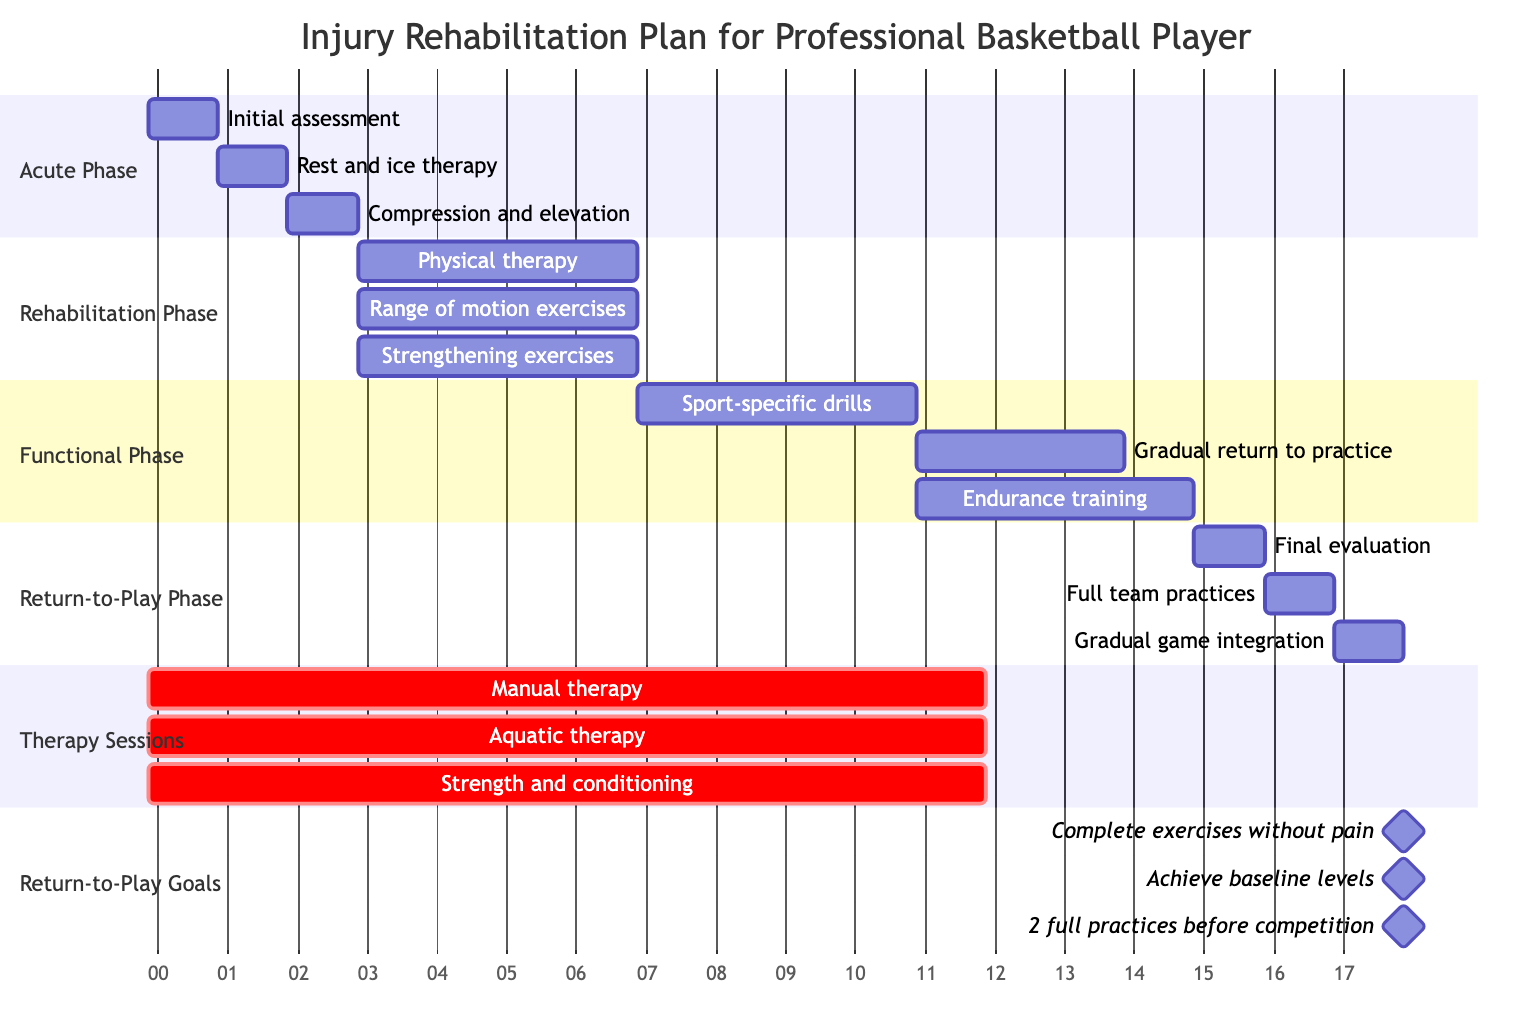What are the activities in the Acute Phase? The Acute Phase has three activities listed: Initial assessment and diagnosis, Rest and ice therapy, Compression and elevation. This information can be found in the 'Acute Phase' section of the Gantt Chart.
Answer: Initial assessment and diagnosis, Rest and ice therapy, Compression and elevation How long does the Functional Phase last? The Functional Phase starts after the Rehabilitation Phase and lasts for 10 weeks total. This is evident in the diagram where the duration of the Functional Phase spans from Weeks 7 to 10.
Answer: 4 weeks What are the therapy sessions scheduled for the entire rehabilitation? Three types of therapy sessions are included in the plan: Manual therapy, Aquatic therapy, and Strength and conditioning. These are marked in the 'Therapy Sessions' section of the Gantt Chart.
Answer: Manual therapy, Aquatic therapy, Strength and conditioning How frequently are strength and conditioning sessions conducted? The diagram states that strength and conditioning sessions occur three times a week. This frequency can be found in the description provided under therapy sessions.
Answer: Three times a week What is the final goal before returning to competition? The final return-to-play goal is to participate in a minimum of 2 full practices before returning to competition. This is detailed in the section on Return-to-Play Goals in the diagram.
Answer: 2 full practices before competition During which phase does endurance training occur? Endurance training takes place in the Functional Phase, as indicated by its placement in the diagram, which outlines activities under the Functional Phase section.
Answer: Functional Phase What is the duration of the Return-to-Play Phase? The Return-to-Play Phase lasts for 3 weeks, as shown in the section where it is indicated that it spans from Weeks 11 to 12.
Answer: 3 weeks What is the frequency of aquatic therapy sessions? The diagram indicates that aquatic therapy sessions are scheduled once a week. This information can be found in the detailed description of therapy sessions.
Answer: Once a week 